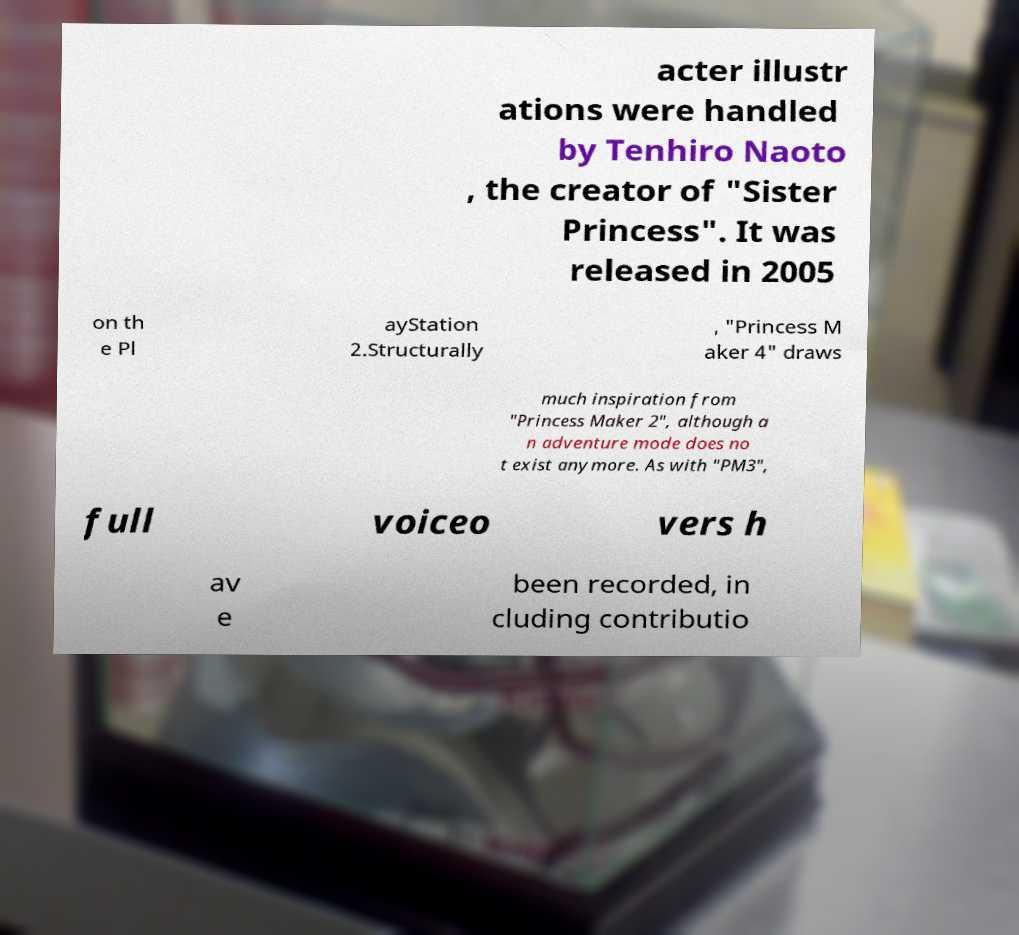What messages or text are displayed in this image? I need them in a readable, typed format. acter illustr ations were handled by Tenhiro Naoto , the creator of "Sister Princess". It was released in 2005 on th e Pl ayStation 2.Structurally , "Princess M aker 4" draws much inspiration from "Princess Maker 2", although a n adventure mode does no t exist anymore. As with "PM3", full voiceo vers h av e been recorded, in cluding contributio 